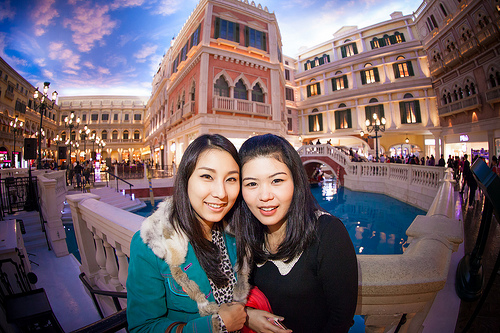<image>
Can you confirm if the girls is behind the fountain? No. The girls is not behind the fountain. From this viewpoint, the girls appears to be positioned elsewhere in the scene. 